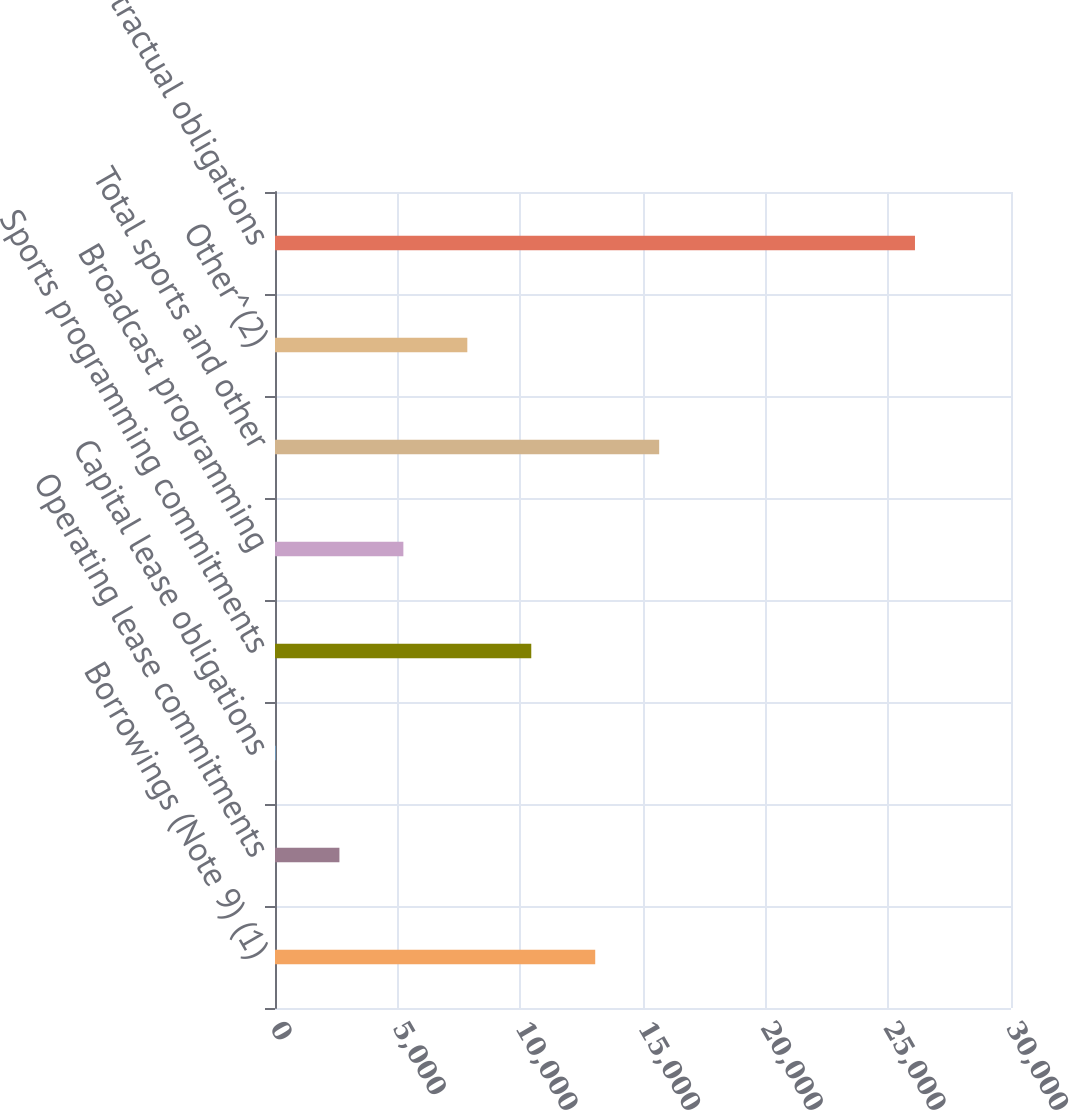Convert chart. <chart><loc_0><loc_0><loc_500><loc_500><bar_chart><fcel>Borrowings (Note 9) (1)<fcel>Operating lease commitments<fcel>Capital lease obligations<fcel>Sports programming commitments<fcel>Broadcast programming<fcel>Total sports and other<fcel>Other^(2)<fcel>Total contractual obligations<nl><fcel>13052.5<fcel>2625.7<fcel>19<fcel>10445.8<fcel>5232.4<fcel>15659.2<fcel>7839.1<fcel>26086<nl></chart> 